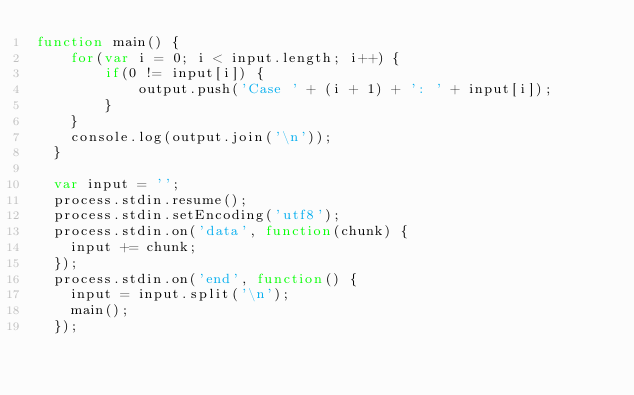Convert code to text. <code><loc_0><loc_0><loc_500><loc_500><_JavaScript_>function main() {
    for(var i = 0; i < input.length; i++) {
        if(0 != input[i]) {
            output.push('Case ' + (i + 1) + ': ' + input[i]);
        }
    }
    console.log(output.join('\n'));
  }
  
  var input = '';  
  process.stdin.resume();
  process.stdin.setEncoding('utf8');
  process.stdin.on('data', function(chunk) {
    input += chunk;
  });
  process.stdin.on('end', function() {
    input = input.split('\n');
    main();
  });</code> 